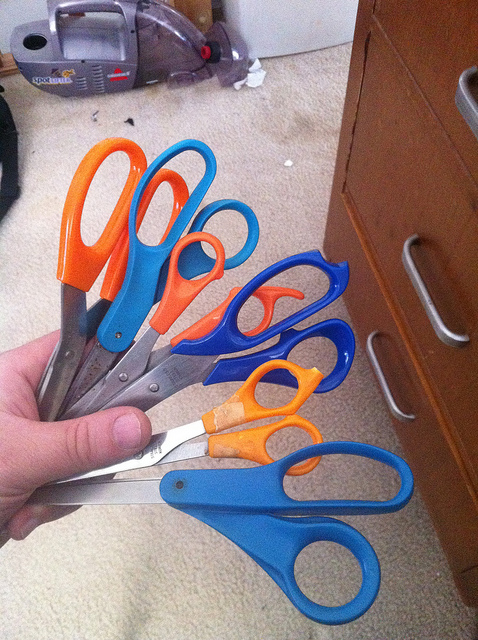What might be the different uses for these varying sizes of scissors? The various sizes of scissors are likely intended for different tasks. The smallest, orange pair might be for delicate cutting or craftwork, while the larger blue pairs could be for general household or office use, capable of cutting through thicker materials. 